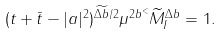Convert formula to latex. <formula><loc_0><loc_0><loc_500><loc_500>( t + \bar { t } - | a | ^ { 2 } ) ^ { \widetilde { \Delta b } / 2 } \mu ^ { 2 b ^ { < } } \widetilde { M } _ { I } ^ { \Delta b } = 1 .</formula> 